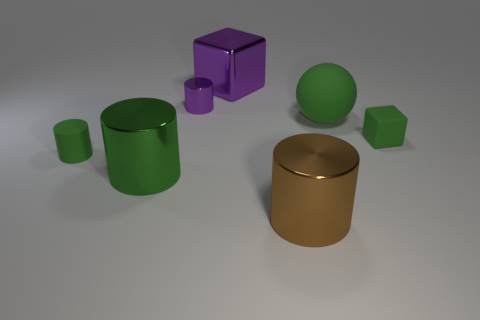There is a object that is right of the big purple metallic thing and on the left side of the big matte ball; what shape is it?
Provide a short and direct response. Cylinder. What material is the sphere that is the same color as the small cube?
Your response must be concise. Rubber. How many blocks are either brown metal objects or small purple metal things?
Ensure brevity in your answer.  0. What size is the metal cylinder that is the same color as the large rubber sphere?
Offer a very short reply. Large. Is the number of metallic things that are right of the big green cylinder less than the number of big metal objects?
Your answer should be very brief. No. There is a metallic cylinder that is both to the left of the large block and in front of the green rubber cube; what color is it?
Your answer should be very brief. Green. How many other objects are the same shape as the brown thing?
Provide a short and direct response. 3. Is the number of spheres that are behind the purple cube less than the number of green spheres that are to the left of the small purple metal cylinder?
Provide a short and direct response. No. Are the big block and the green object behind the green matte block made of the same material?
Offer a terse response. No. Are there more purple matte cubes than metallic things?
Give a very brief answer. No. 